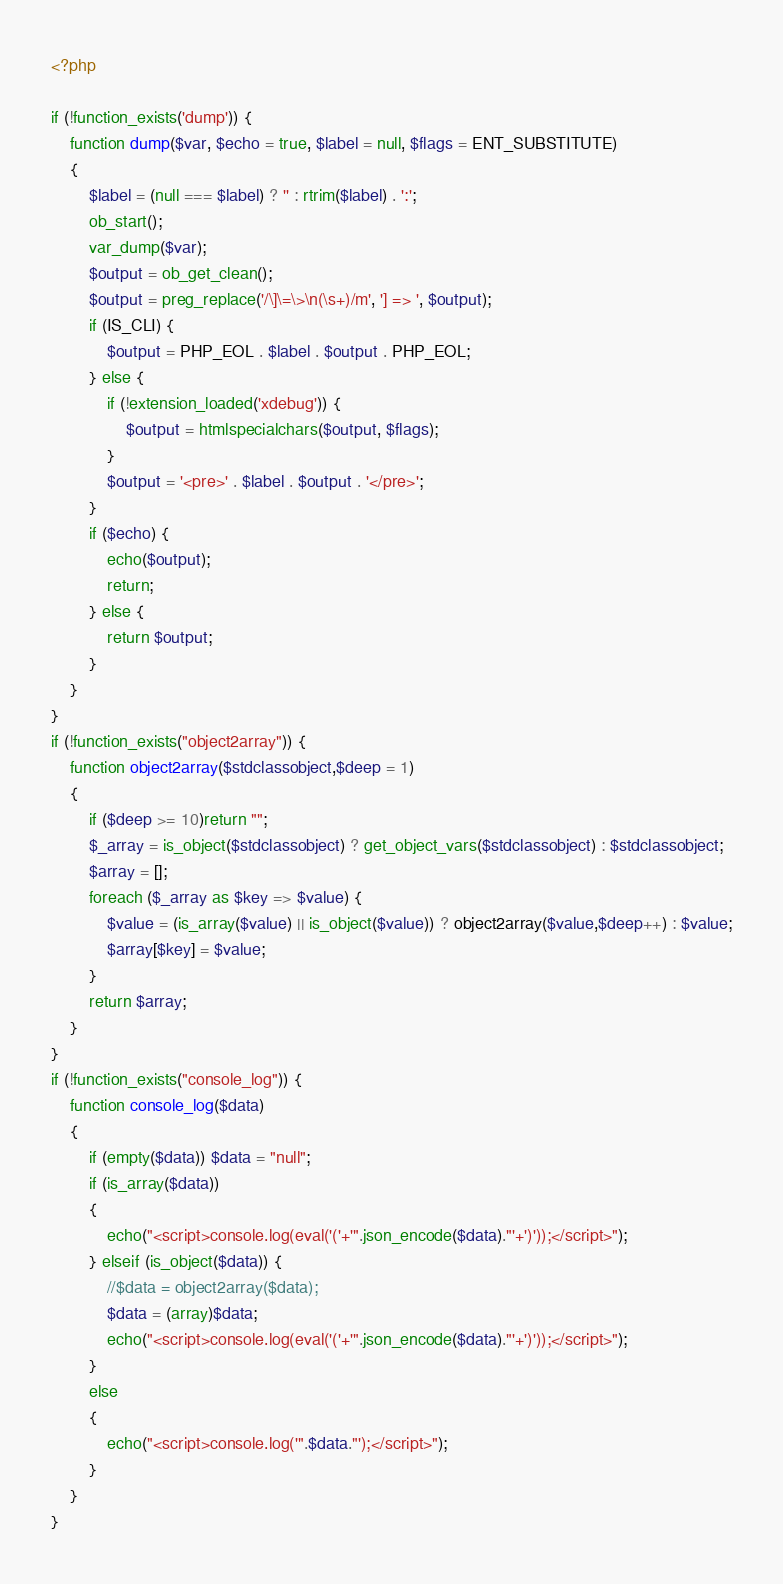<code> <loc_0><loc_0><loc_500><loc_500><_PHP_><?php

if (!function_exists('dump')) {
	function dump($var, $echo = true, $label = null, $flags = ENT_SUBSTITUTE)
	{
        $label = (null === $label) ? '' : rtrim($label) . ':';
        ob_start();
        var_dump($var);
        $output = ob_get_clean();
        $output = preg_replace('/\]\=\>\n(\s+)/m', '] => ', $output);
        if (IS_CLI) {
            $output = PHP_EOL . $label . $output . PHP_EOL;
        } else {
            if (!extension_loaded('xdebug')) {
                $output = htmlspecialchars($output, $flags);
            }
            $output = '<pre>' . $label . $output . '</pre>';
        }
        if ($echo) {
            echo($output);
            return;
        } else {
            return $output;
        }
	}
}
if (!function_exists("object2array")) {
    function object2array($stdclassobject,$deep = 1)
    {
        if ($deep >= 10)return "";
        $_array = is_object($stdclassobject) ? get_object_vars($stdclassobject) : $stdclassobject;
        $array = [];
        foreach ($_array as $key => $value) {
            $value = (is_array($value) || is_object($value)) ? object2array($value,$deep++) : $value;
            $array[$key] = $value;
        }
        return $array;
    }
}
if (!function_exists("console_log")) {
    function console_log($data)
    {
        if (empty($data)) $data = "null";
        if (is_array($data))
        {
            echo("<script>console.log(eval('('+'".json_encode($data)."'+')'));</script>");
        } elseif (is_object($data)) {
            //$data = object2array($data);
            $data = (array)$data;
            echo("<script>console.log(eval('('+'".json_encode($data)."'+')'));</script>");
        }
        else
        {
            echo("<script>console.log('".$data."');</script>");
        }
    }
}
</code> 